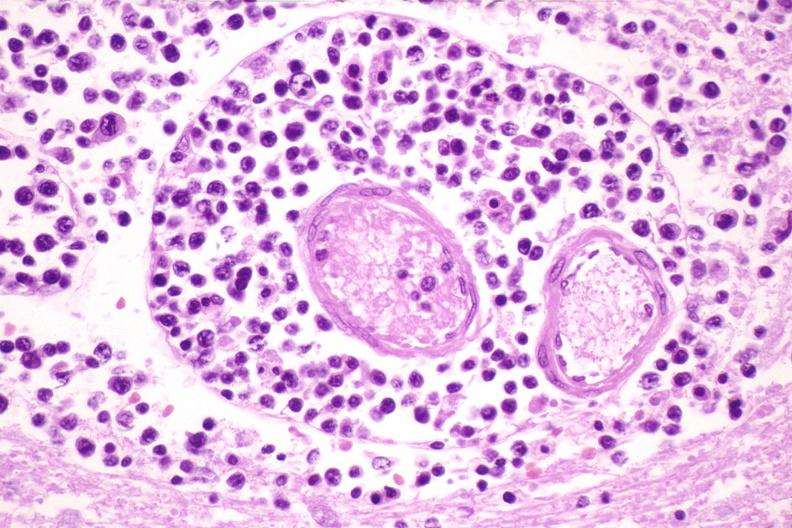what does this image show?
Answer the question using a single word or phrase. Brain lymphoma 